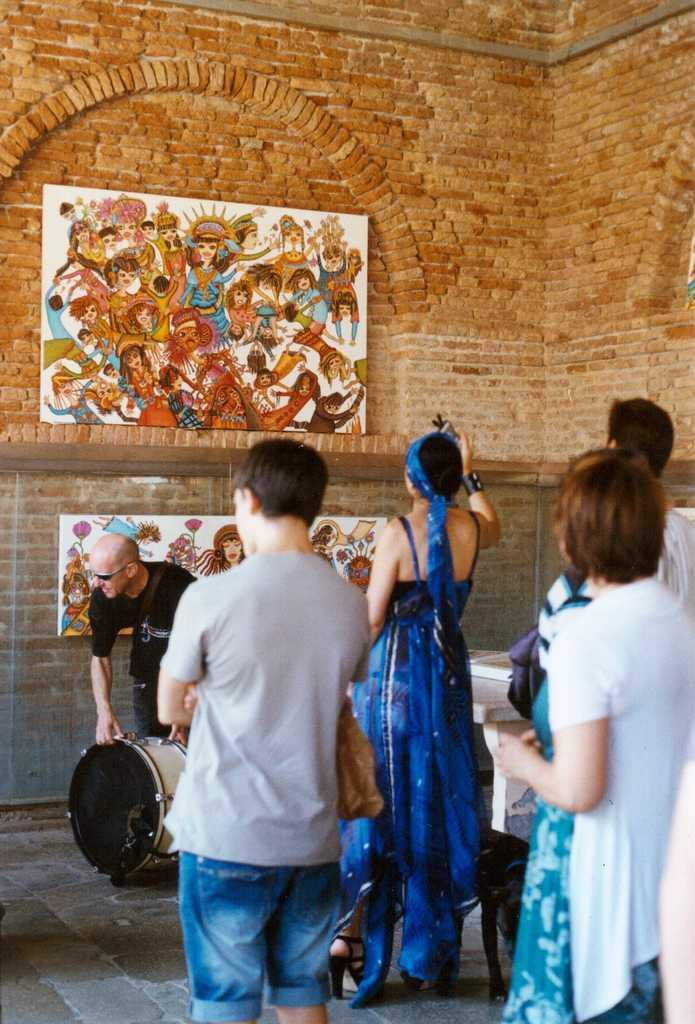How many people are in the image? There is a group of persons standing in the image. What else can be seen in the image besides the group of persons? There is a painting in the image. Where is the painting located in the image? The painting is attached to a wall. What is the color of the wall in the image? The wall has a red brick color. What type of cap can be seen on the cave in the image? There is no cave present in the image, and therefore no cap can be seen on it. 